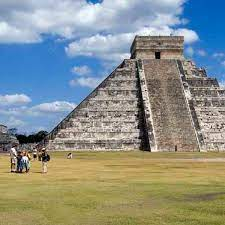Describe the following image. The image showcases the magnificent ancient Mayan pyramid of Chichen Itza in the Yucatan Peninsula, Mexico. This monumental stone pyramid stands tall with its distinctive stepped sides, culminating in a flat platform that hosts a small temple at the top. The backdrop of the picture is a stunning clear blue sky with gentle clouds, adding to the serenity and grandeur of the scene. Surrounding the pyramid is a vast grassy expanse, which contrasts beautifully with the grey stone structure. Tourists are visible around the base, appearing as small figures next to the towering pyramid, highlighting its colossal scale. The photo captures the pyramid from a distance, allowing the viewer to fully appreciate its imposing presence and the skillful architecture of the ancient Mayans. The vibrant colors and the historical significance embodied in this image offer a deep sense of cultural heritage. 